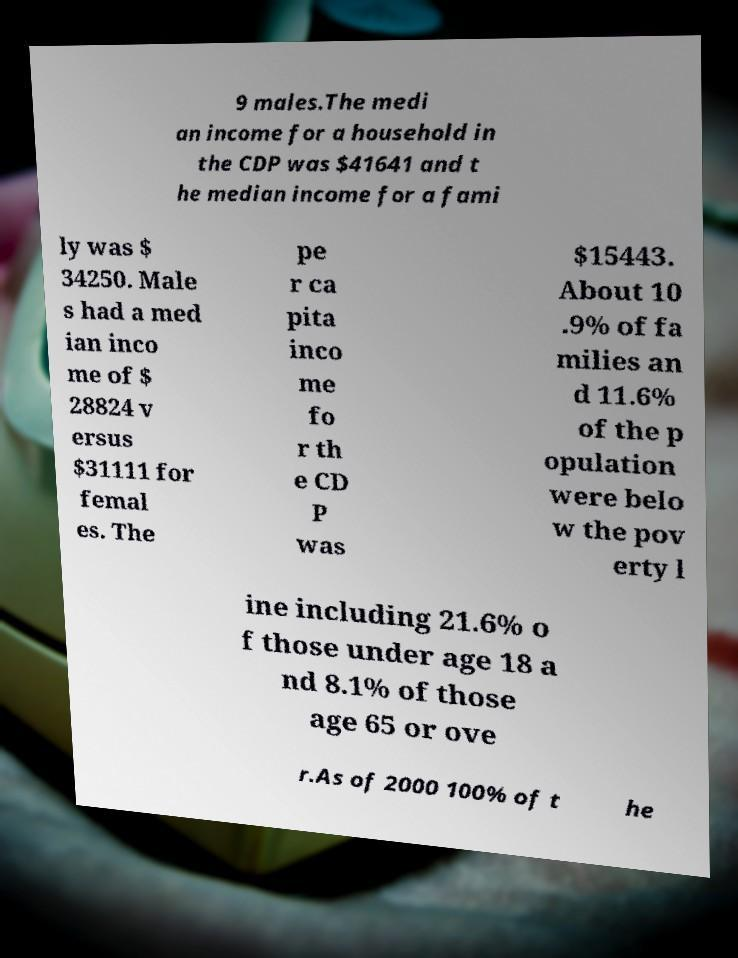Can you accurately transcribe the text from the provided image for me? 9 males.The medi an income for a household in the CDP was $41641 and t he median income for a fami ly was $ 34250. Male s had a med ian inco me of $ 28824 v ersus $31111 for femal es. The pe r ca pita inco me fo r th e CD P was $15443. About 10 .9% of fa milies an d 11.6% of the p opulation were belo w the pov erty l ine including 21.6% o f those under age 18 a nd 8.1% of those age 65 or ove r.As of 2000 100% of t he 